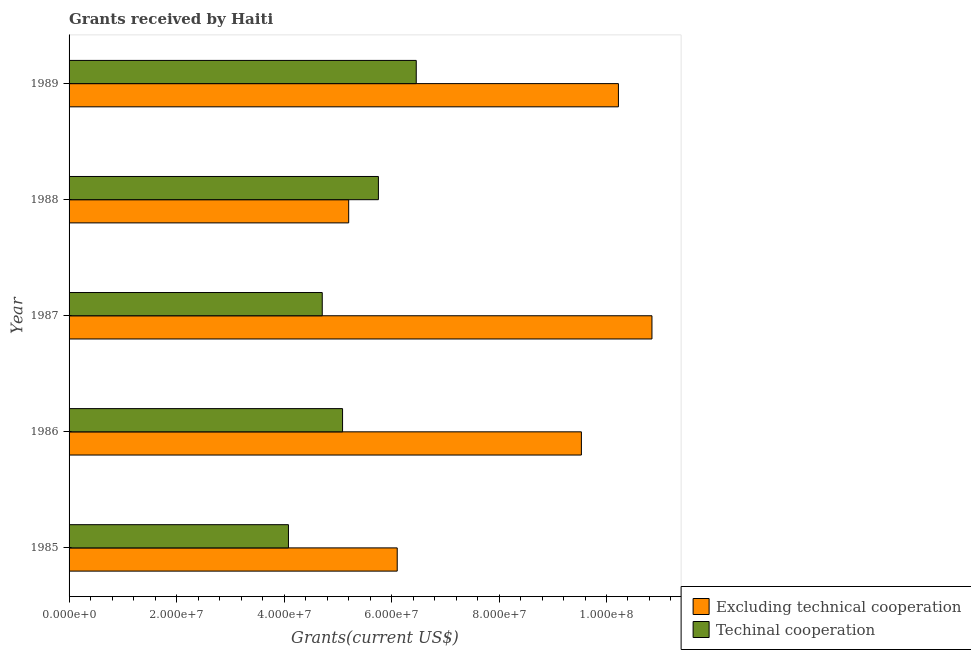How many different coloured bars are there?
Give a very brief answer. 2. Are the number of bars per tick equal to the number of legend labels?
Give a very brief answer. Yes. Are the number of bars on each tick of the Y-axis equal?
Offer a terse response. Yes. How many bars are there on the 4th tick from the top?
Make the answer very short. 2. What is the label of the 2nd group of bars from the top?
Give a very brief answer. 1988. What is the amount of grants received(including technical cooperation) in 1988?
Your answer should be compact. 5.76e+07. Across all years, what is the maximum amount of grants received(including technical cooperation)?
Give a very brief answer. 6.46e+07. Across all years, what is the minimum amount of grants received(excluding technical cooperation)?
Give a very brief answer. 5.20e+07. In which year was the amount of grants received(including technical cooperation) maximum?
Offer a terse response. 1989. In which year was the amount of grants received(including technical cooperation) minimum?
Offer a very short reply. 1985. What is the total amount of grants received(excluding technical cooperation) in the graph?
Offer a terse response. 4.19e+08. What is the difference between the amount of grants received(including technical cooperation) in 1986 and that in 1988?
Your answer should be very brief. -6.67e+06. What is the difference between the amount of grants received(including technical cooperation) in 1989 and the amount of grants received(excluding technical cooperation) in 1987?
Your answer should be very brief. -4.39e+07. What is the average amount of grants received(excluding technical cooperation) per year?
Offer a terse response. 8.38e+07. In the year 1985, what is the difference between the amount of grants received(including technical cooperation) and amount of grants received(excluding technical cooperation)?
Keep it short and to the point. -2.02e+07. What is the ratio of the amount of grants received(excluding technical cooperation) in 1987 to that in 1988?
Your response must be concise. 2.08. Is the difference between the amount of grants received(excluding technical cooperation) in 1985 and 1987 greater than the difference between the amount of grants received(including technical cooperation) in 1985 and 1987?
Offer a terse response. No. What is the difference between the highest and the second highest amount of grants received(including technical cooperation)?
Keep it short and to the point. 7.04e+06. What is the difference between the highest and the lowest amount of grants received(excluding technical cooperation)?
Your response must be concise. 5.64e+07. Is the sum of the amount of grants received(including technical cooperation) in 1987 and 1988 greater than the maximum amount of grants received(excluding technical cooperation) across all years?
Keep it short and to the point. No. What does the 1st bar from the top in 1987 represents?
Your response must be concise. Techinal cooperation. What does the 1st bar from the bottom in 1987 represents?
Ensure brevity in your answer.  Excluding technical cooperation. How many years are there in the graph?
Ensure brevity in your answer.  5. What is the difference between two consecutive major ticks on the X-axis?
Give a very brief answer. 2.00e+07. Are the values on the major ticks of X-axis written in scientific E-notation?
Offer a very short reply. Yes. Does the graph contain any zero values?
Offer a terse response. No. Does the graph contain grids?
Your answer should be compact. No. Where does the legend appear in the graph?
Keep it short and to the point. Bottom right. How are the legend labels stacked?
Your answer should be very brief. Vertical. What is the title of the graph?
Offer a terse response. Grants received by Haiti. What is the label or title of the X-axis?
Provide a short and direct response. Grants(current US$). What is the Grants(current US$) of Excluding technical cooperation in 1985?
Your response must be concise. 6.11e+07. What is the Grants(current US$) of Techinal cooperation in 1985?
Make the answer very short. 4.08e+07. What is the Grants(current US$) of Excluding technical cooperation in 1986?
Provide a short and direct response. 9.53e+07. What is the Grants(current US$) in Techinal cooperation in 1986?
Give a very brief answer. 5.09e+07. What is the Grants(current US$) of Excluding technical cooperation in 1987?
Make the answer very short. 1.08e+08. What is the Grants(current US$) of Techinal cooperation in 1987?
Your answer should be very brief. 4.71e+07. What is the Grants(current US$) of Excluding technical cooperation in 1988?
Keep it short and to the point. 5.20e+07. What is the Grants(current US$) of Techinal cooperation in 1988?
Ensure brevity in your answer.  5.76e+07. What is the Grants(current US$) in Excluding technical cooperation in 1989?
Ensure brevity in your answer.  1.02e+08. What is the Grants(current US$) of Techinal cooperation in 1989?
Your response must be concise. 6.46e+07. Across all years, what is the maximum Grants(current US$) of Excluding technical cooperation?
Provide a succinct answer. 1.08e+08. Across all years, what is the maximum Grants(current US$) in Techinal cooperation?
Your answer should be very brief. 6.46e+07. Across all years, what is the minimum Grants(current US$) of Excluding technical cooperation?
Your answer should be very brief. 5.20e+07. Across all years, what is the minimum Grants(current US$) of Techinal cooperation?
Make the answer very short. 4.08e+07. What is the total Grants(current US$) of Excluding technical cooperation in the graph?
Keep it short and to the point. 4.19e+08. What is the total Grants(current US$) in Techinal cooperation in the graph?
Your answer should be compact. 2.61e+08. What is the difference between the Grants(current US$) of Excluding technical cooperation in 1985 and that in 1986?
Ensure brevity in your answer.  -3.43e+07. What is the difference between the Grants(current US$) in Techinal cooperation in 1985 and that in 1986?
Your response must be concise. -1.01e+07. What is the difference between the Grants(current US$) in Excluding technical cooperation in 1985 and that in 1987?
Offer a very short reply. -4.74e+07. What is the difference between the Grants(current US$) of Techinal cooperation in 1985 and that in 1987?
Keep it short and to the point. -6.29e+06. What is the difference between the Grants(current US$) in Excluding technical cooperation in 1985 and that in 1988?
Provide a succinct answer. 9.03e+06. What is the difference between the Grants(current US$) in Techinal cooperation in 1985 and that in 1988?
Your response must be concise. -1.67e+07. What is the difference between the Grants(current US$) of Excluding technical cooperation in 1985 and that in 1989?
Provide a short and direct response. -4.12e+07. What is the difference between the Grants(current US$) in Techinal cooperation in 1985 and that in 1989?
Offer a very short reply. -2.38e+07. What is the difference between the Grants(current US$) of Excluding technical cooperation in 1986 and that in 1987?
Give a very brief answer. -1.31e+07. What is the difference between the Grants(current US$) in Techinal cooperation in 1986 and that in 1987?
Provide a succinct answer. 3.78e+06. What is the difference between the Grants(current US$) in Excluding technical cooperation in 1986 and that in 1988?
Offer a very short reply. 4.33e+07. What is the difference between the Grants(current US$) of Techinal cooperation in 1986 and that in 1988?
Offer a very short reply. -6.67e+06. What is the difference between the Grants(current US$) in Excluding technical cooperation in 1986 and that in 1989?
Give a very brief answer. -6.89e+06. What is the difference between the Grants(current US$) in Techinal cooperation in 1986 and that in 1989?
Offer a very short reply. -1.37e+07. What is the difference between the Grants(current US$) in Excluding technical cooperation in 1987 and that in 1988?
Offer a terse response. 5.64e+07. What is the difference between the Grants(current US$) of Techinal cooperation in 1987 and that in 1988?
Give a very brief answer. -1.04e+07. What is the difference between the Grants(current US$) in Excluding technical cooperation in 1987 and that in 1989?
Provide a short and direct response. 6.24e+06. What is the difference between the Grants(current US$) of Techinal cooperation in 1987 and that in 1989?
Your answer should be very brief. -1.75e+07. What is the difference between the Grants(current US$) in Excluding technical cooperation in 1988 and that in 1989?
Your response must be concise. -5.02e+07. What is the difference between the Grants(current US$) of Techinal cooperation in 1988 and that in 1989?
Provide a short and direct response. -7.04e+06. What is the difference between the Grants(current US$) in Excluding technical cooperation in 1985 and the Grants(current US$) in Techinal cooperation in 1986?
Give a very brief answer. 1.02e+07. What is the difference between the Grants(current US$) of Excluding technical cooperation in 1985 and the Grants(current US$) of Techinal cooperation in 1987?
Provide a succinct answer. 1.40e+07. What is the difference between the Grants(current US$) in Excluding technical cooperation in 1985 and the Grants(current US$) in Techinal cooperation in 1988?
Give a very brief answer. 3.50e+06. What is the difference between the Grants(current US$) of Excluding technical cooperation in 1985 and the Grants(current US$) of Techinal cooperation in 1989?
Ensure brevity in your answer.  -3.54e+06. What is the difference between the Grants(current US$) in Excluding technical cooperation in 1986 and the Grants(current US$) in Techinal cooperation in 1987?
Provide a short and direct response. 4.82e+07. What is the difference between the Grants(current US$) in Excluding technical cooperation in 1986 and the Grants(current US$) in Techinal cooperation in 1988?
Your response must be concise. 3.78e+07. What is the difference between the Grants(current US$) of Excluding technical cooperation in 1986 and the Grants(current US$) of Techinal cooperation in 1989?
Provide a short and direct response. 3.07e+07. What is the difference between the Grants(current US$) of Excluding technical cooperation in 1987 and the Grants(current US$) of Techinal cooperation in 1988?
Ensure brevity in your answer.  5.09e+07. What is the difference between the Grants(current US$) in Excluding technical cooperation in 1987 and the Grants(current US$) in Techinal cooperation in 1989?
Offer a very short reply. 4.39e+07. What is the difference between the Grants(current US$) in Excluding technical cooperation in 1988 and the Grants(current US$) in Techinal cooperation in 1989?
Your response must be concise. -1.26e+07. What is the average Grants(current US$) of Excluding technical cooperation per year?
Your response must be concise. 8.38e+07. What is the average Grants(current US$) of Techinal cooperation per year?
Make the answer very short. 5.22e+07. In the year 1985, what is the difference between the Grants(current US$) in Excluding technical cooperation and Grants(current US$) in Techinal cooperation?
Your response must be concise. 2.02e+07. In the year 1986, what is the difference between the Grants(current US$) in Excluding technical cooperation and Grants(current US$) in Techinal cooperation?
Provide a succinct answer. 4.44e+07. In the year 1987, what is the difference between the Grants(current US$) in Excluding technical cooperation and Grants(current US$) in Techinal cooperation?
Your response must be concise. 6.14e+07. In the year 1988, what is the difference between the Grants(current US$) in Excluding technical cooperation and Grants(current US$) in Techinal cooperation?
Make the answer very short. -5.53e+06. In the year 1989, what is the difference between the Grants(current US$) in Excluding technical cooperation and Grants(current US$) in Techinal cooperation?
Provide a short and direct response. 3.76e+07. What is the ratio of the Grants(current US$) in Excluding technical cooperation in 1985 to that in 1986?
Give a very brief answer. 0.64. What is the ratio of the Grants(current US$) of Techinal cooperation in 1985 to that in 1986?
Your answer should be compact. 0.8. What is the ratio of the Grants(current US$) in Excluding technical cooperation in 1985 to that in 1987?
Provide a short and direct response. 0.56. What is the ratio of the Grants(current US$) of Techinal cooperation in 1985 to that in 1987?
Provide a succinct answer. 0.87. What is the ratio of the Grants(current US$) in Excluding technical cooperation in 1985 to that in 1988?
Keep it short and to the point. 1.17. What is the ratio of the Grants(current US$) in Techinal cooperation in 1985 to that in 1988?
Your response must be concise. 0.71. What is the ratio of the Grants(current US$) in Excluding technical cooperation in 1985 to that in 1989?
Your response must be concise. 0.6. What is the ratio of the Grants(current US$) in Techinal cooperation in 1985 to that in 1989?
Offer a terse response. 0.63. What is the ratio of the Grants(current US$) in Excluding technical cooperation in 1986 to that in 1987?
Your response must be concise. 0.88. What is the ratio of the Grants(current US$) in Techinal cooperation in 1986 to that in 1987?
Ensure brevity in your answer.  1.08. What is the ratio of the Grants(current US$) of Excluding technical cooperation in 1986 to that in 1988?
Offer a very short reply. 1.83. What is the ratio of the Grants(current US$) in Techinal cooperation in 1986 to that in 1988?
Make the answer very short. 0.88. What is the ratio of the Grants(current US$) in Excluding technical cooperation in 1986 to that in 1989?
Your response must be concise. 0.93. What is the ratio of the Grants(current US$) in Techinal cooperation in 1986 to that in 1989?
Ensure brevity in your answer.  0.79. What is the ratio of the Grants(current US$) of Excluding technical cooperation in 1987 to that in 1988?
Make the answer very short. 2.08. What is the ratio of the Grants(current US$) in Techinal cooperation in 1987 to that in 1988?
Your answer should be very brief. 0.82. What is the ratio of the Grants(current US$) in Excluding technical cooperation in 1987 to that in 1989?
Your answer should be very brief. 1.06. What is the ratio of the Grants(current US$) of Techinal cooperation in 1987 to that in 1989?
Give a very brief answer. 0.73. What is the ratio of the Grants(current US$) of Excluding technical cooperation in 1988 to that in 1989?
Your answer should be compact. 0.51. What is the ratio of the Grants(current US$) in Techinal cooperation in 1988 to that in 1989?
Provide a short and direct response. 0.89. What is the difference between the highest and the second highest Grants(current US$) in Excluding technical cooperation?
Make the answer very short. 6.24e+06. What is the difference between the highest and the second highest Grants(current US$) of Techinal cooperation?
Ensure brevity in your answer.  7.04e+06. What is the difference between the highest and the lowest Grants(current US$) in Excluding technical cooperation?
Offer a very short reply. 5.64e+07. What is the difference between the highest and the lowest Grants(current US$) in Techinal cooperation?
Your answer should be compact. 2.38e+07. 